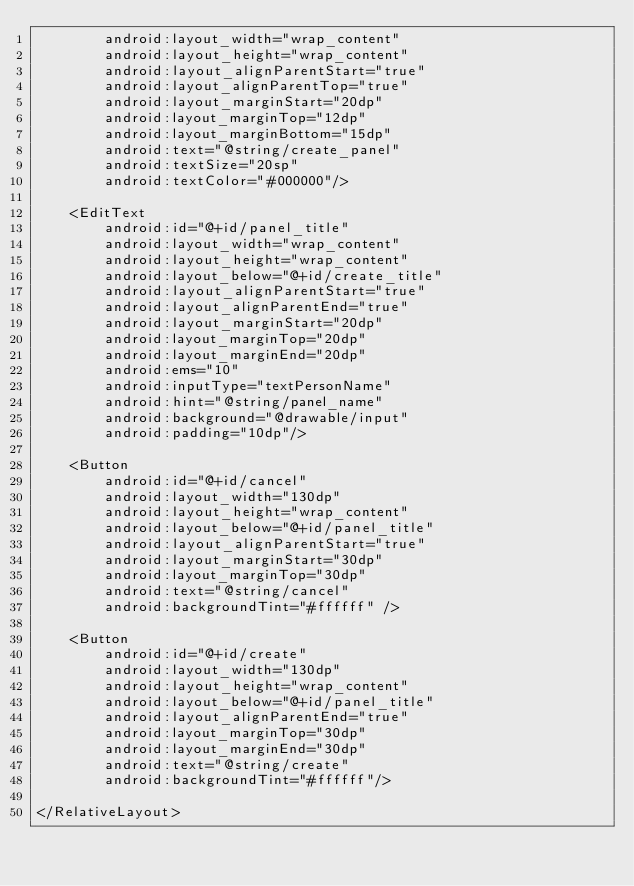<code> <loc_0><loc_0><loc_500><loc_500><_XML_>        android:layout_width="wrap_content"
        android:layout_height="wrap_content"
        android:layout_alignParentStart="true"
        android:layout_alignParentTop="true"
        android:layout_marginStart="20dp"
        android:layout_marginTop="12dp"
        android:layout_marginBottom="15dp"
        android:text="@string/create_panel"
        android:textSize="20sp"
        android:textColor="#000000"/>

    <EditText
        android:id="@+id/panel_title"
        android:layout_width="wrap_content"
        android:layout_height="wrap_content"
        android:layout_below="@+id/create_title"
        android:layout_alignParentStart="true"
        android:layout_alignParentEnd="true"
        android:layout_marginStart="20dp"
        android:layout_marginTop="20dp"
        android:layout_marginEnd="20dp"
        android:ems="10"
        android:inputType="textPersonName"
        android:hint="@string/panel_name"
        android:background="@drawable/input"
        android:padding="10dp"/>

    <Button
        android:id="@+id/cancel"
        android:layout_width="130dp"
        android:layout_height="wrap_content"
        android:layout_below="@+id/panel_title"
        android:layout_alignParentStart="true"
        android:layout_marginStart="30dp"
        android:layout_marginTop="30dp"
        android:text="@string/cancel"
        android:backgroundTint="#ffffff" />

    <Button
        android:id="@+id/create"
        android:layout_width="130dp"
        android:layout_height="wrap_content"
        android:layout_below="@+id/panel_title"
        android:layout_alignParentEnd="true"
        android:layout_marginTop="30dp"
        android:layout_marginEnd="30dp"
        android:text="@string/create"
        android:backgroundTint="#ffffff"/>

</RelativeLayout></code> 